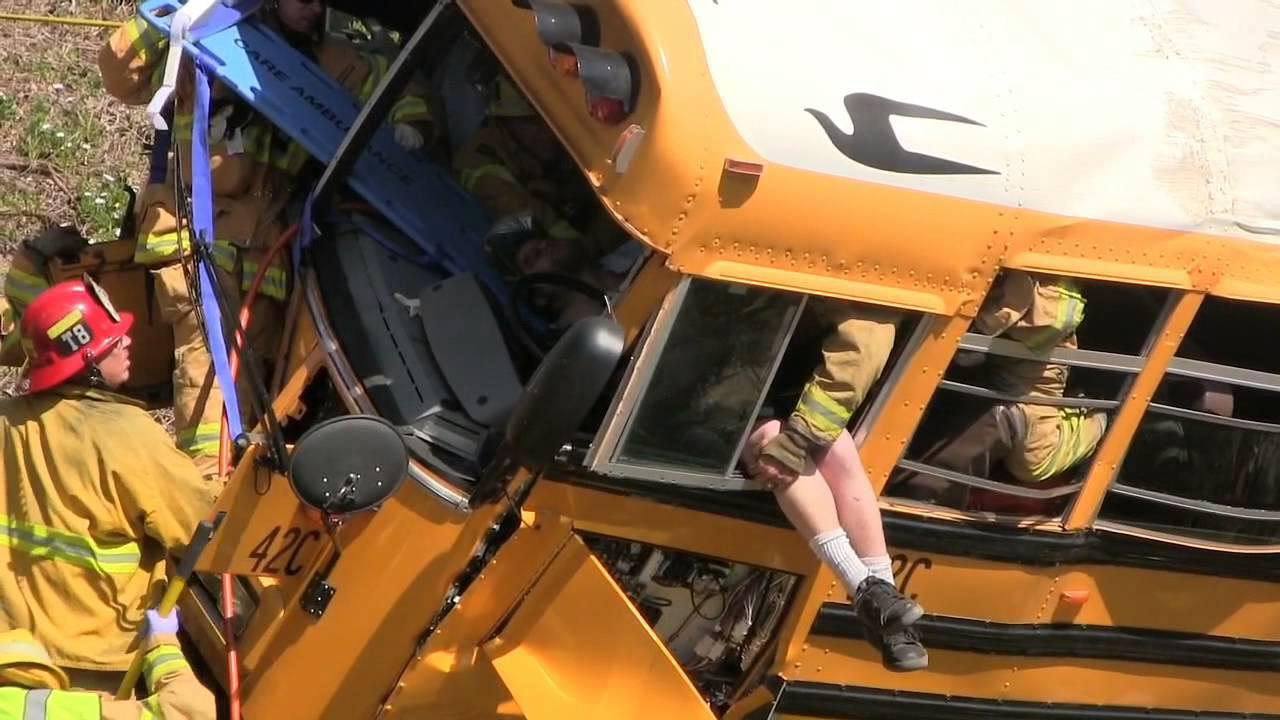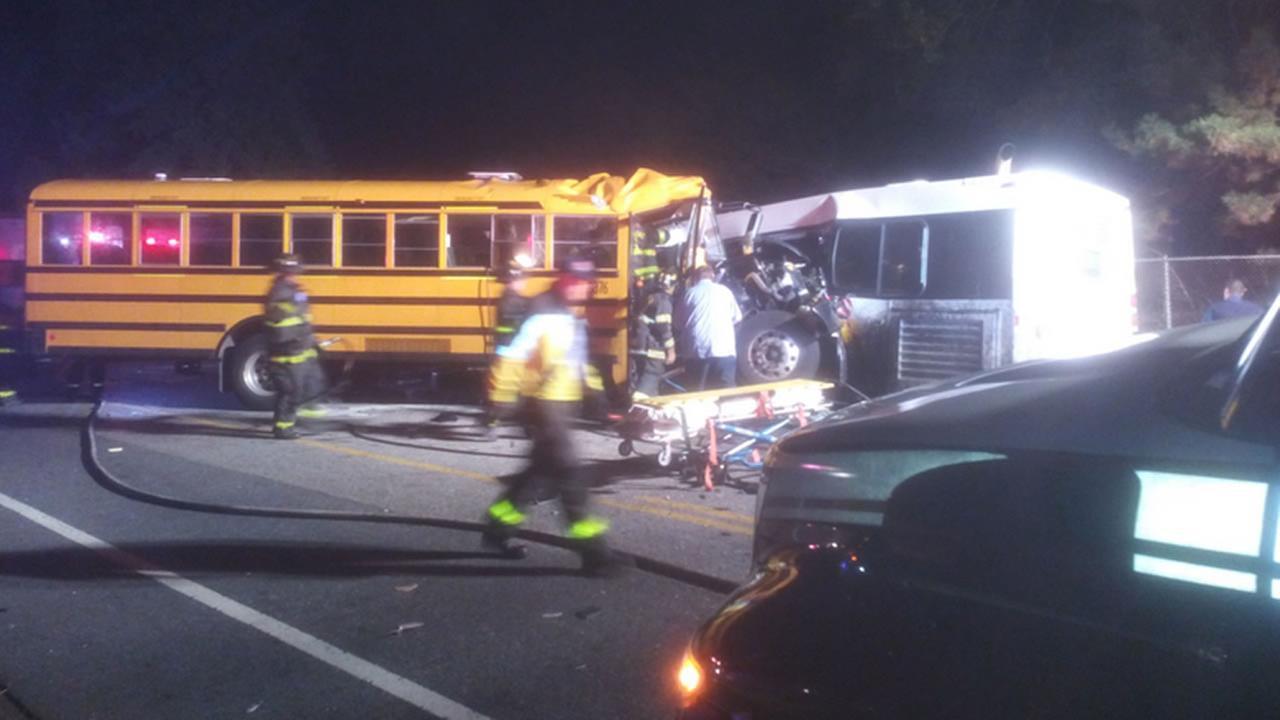The first image is the image on the left, the second image is the image on the right. Evaluate the accuracy of this statement regarding the images: "The right image shows a large tow-truck with a flat-fronted bus tilted behind it and overlapping another bus, on a road with white foam on it.". Is it true? Answer yes or no. No. The first image is the image on the left, the second image is the image on the right. Examine the images to the left and right. Is the description "Exactly one bus is on a truck." accurate? Answer yes or no. No. 